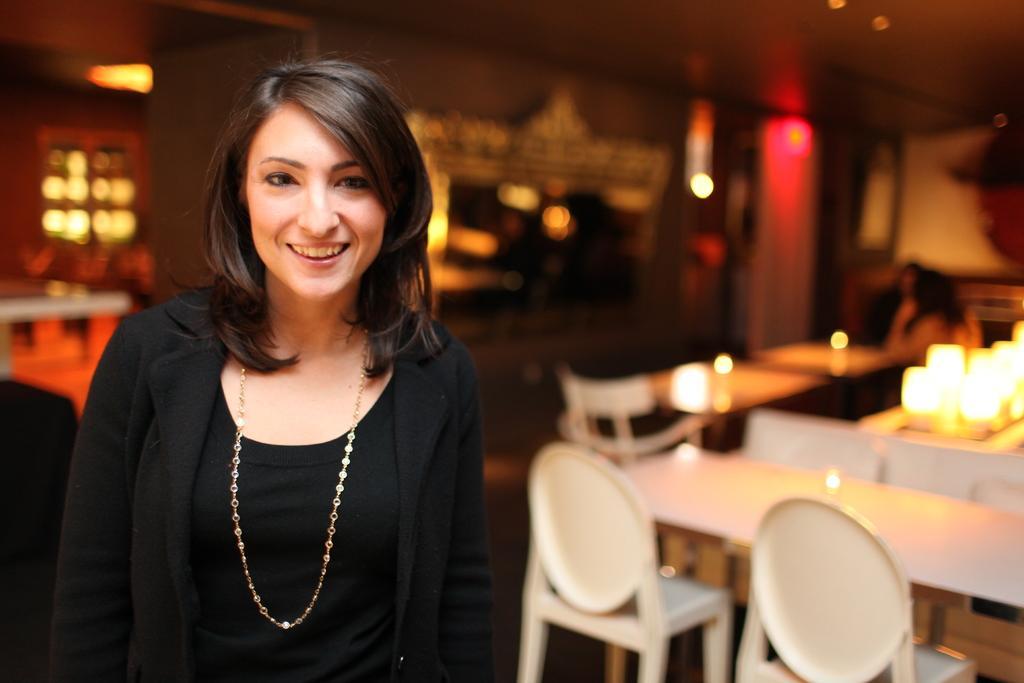Could you give a brief overview of what you see in this image? In this image I can see a woman is standing, I can also see a smile on her face. In the background I can see number of chair and tables. 